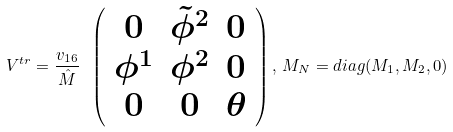Convert formula to latex. <formula><loc_0><loc_0><loc_500><loc_500>V ^ { t r } = \frac { v _ { 1 6 } } { \hat { M } } \ \left ( \begin{array} { c c c } 0 & \tilde { \phi } ^ { 2 } & 0 \\ \phi ^ { 1 } & \phi ^ { 2 } & 0 \\ 0 & 0 & \theta \end{array} \right ) , \, M _ { N } = d i a g ( M _ { 1 } , M _ { 2 } , 0 )</formula> 